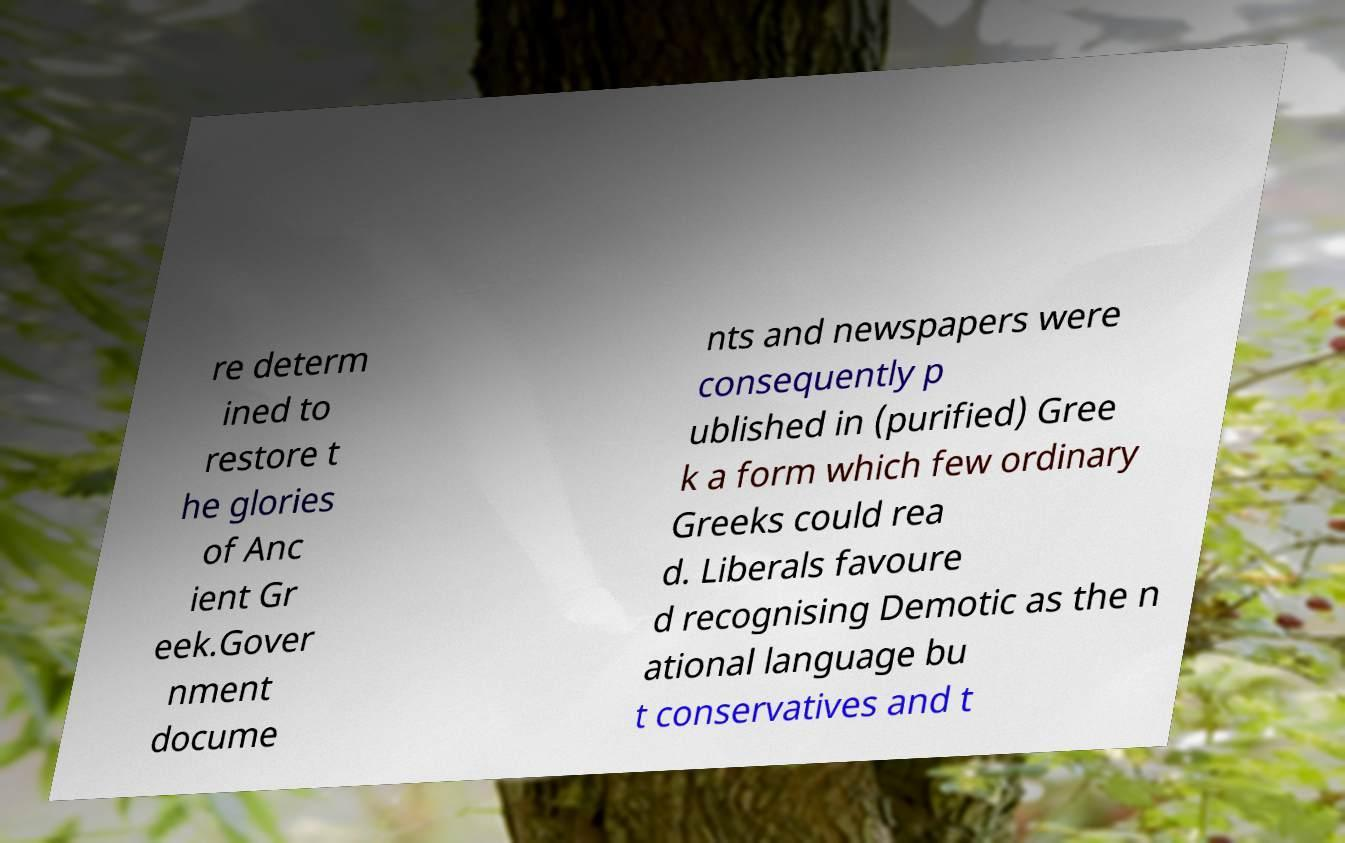There's text embedded in this image that I need extracted. Can you transcribe it verbatim? re determ ined to restore t he glories of Anc ient Gr eek.Gover nment docume nts and newspapers were consequently p ublished in (purified) Gree k a form which few ordinary Greeks could rea d. Liberals favoure d recognising Demotic as the n ational language bu t conservatives and t 